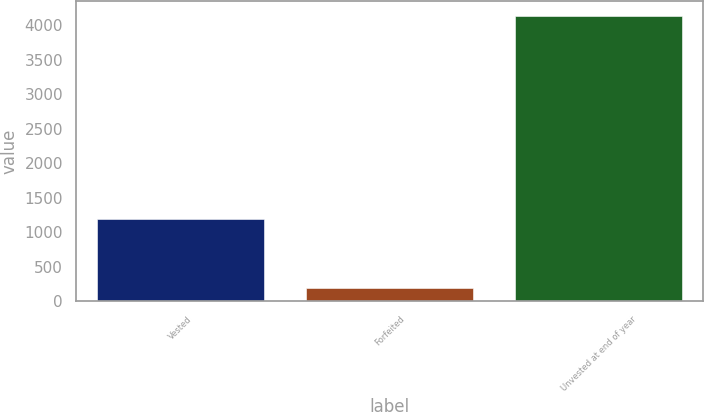Convert chart. <chart><loc_0><loc_0><loc_500><loc_500><bar_chart><fcel>Vested<fcel>Forfeited<fcel>Unvested at end of year<nl><fcel>1186<fcel>188<fcel>4138<nl></chart> 